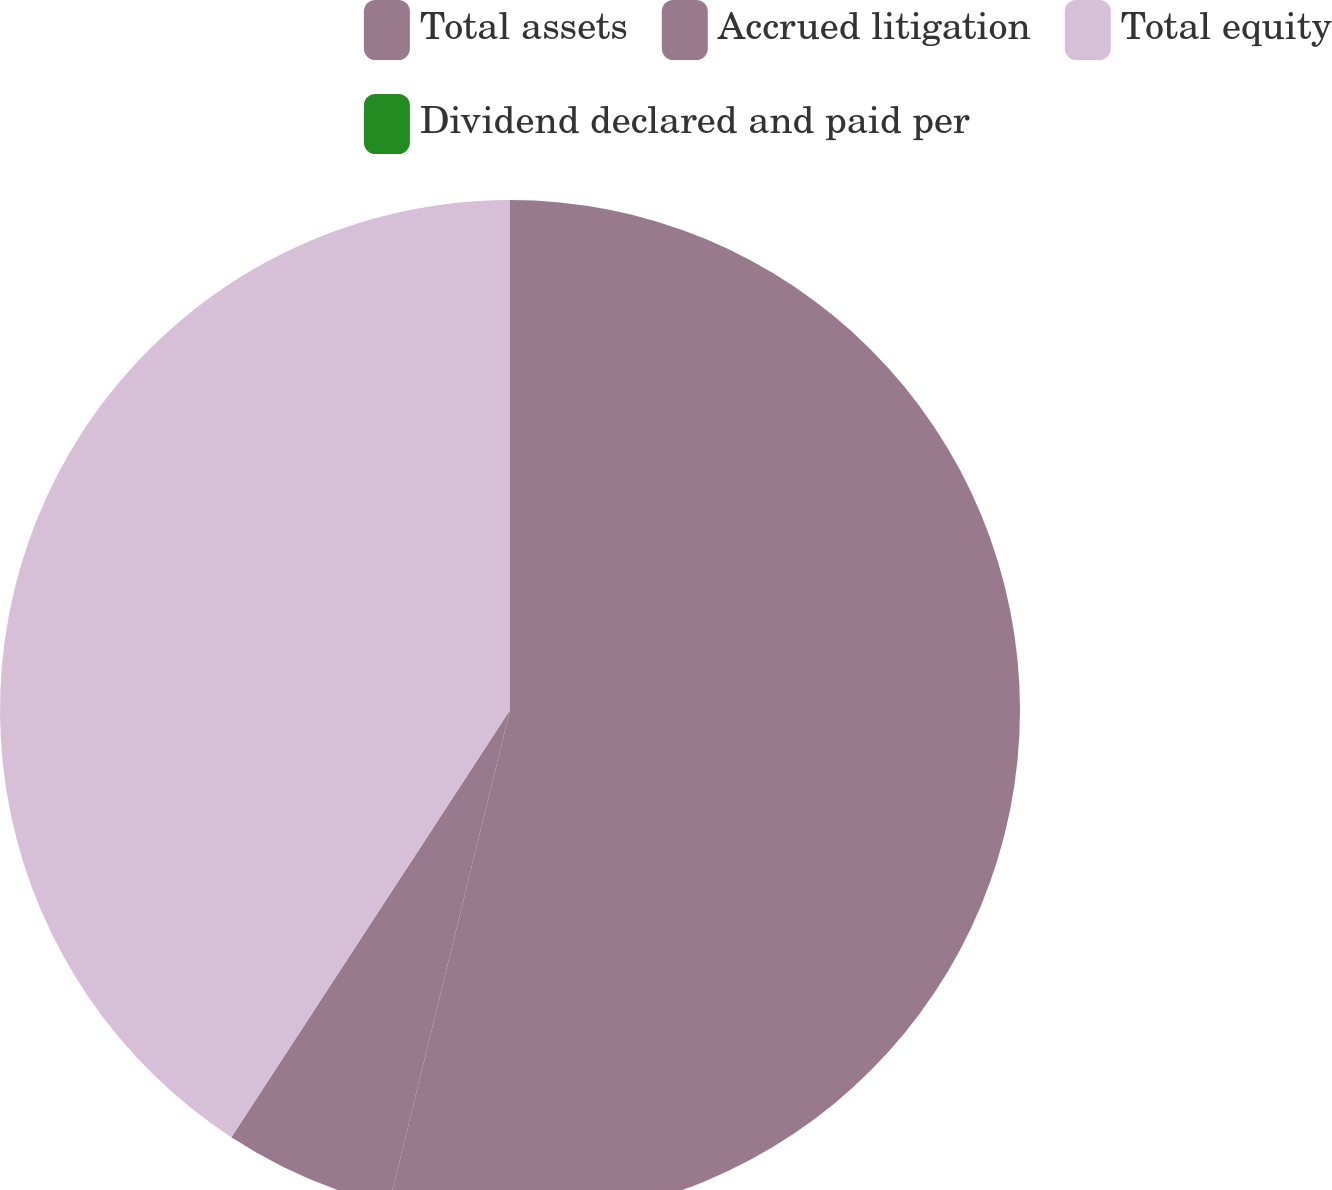<chart> <loc_0><loc_0><loc_500><loc_500><pie_chart><fcel>Total assets<fcel>Accrued litigation<fcel>Total equity<fcel>Dividend declared and paid per<nl><fcel>53.82%<fcel>5.38%<fcel>40.8%<fcel>0.0%<nl></chart> 